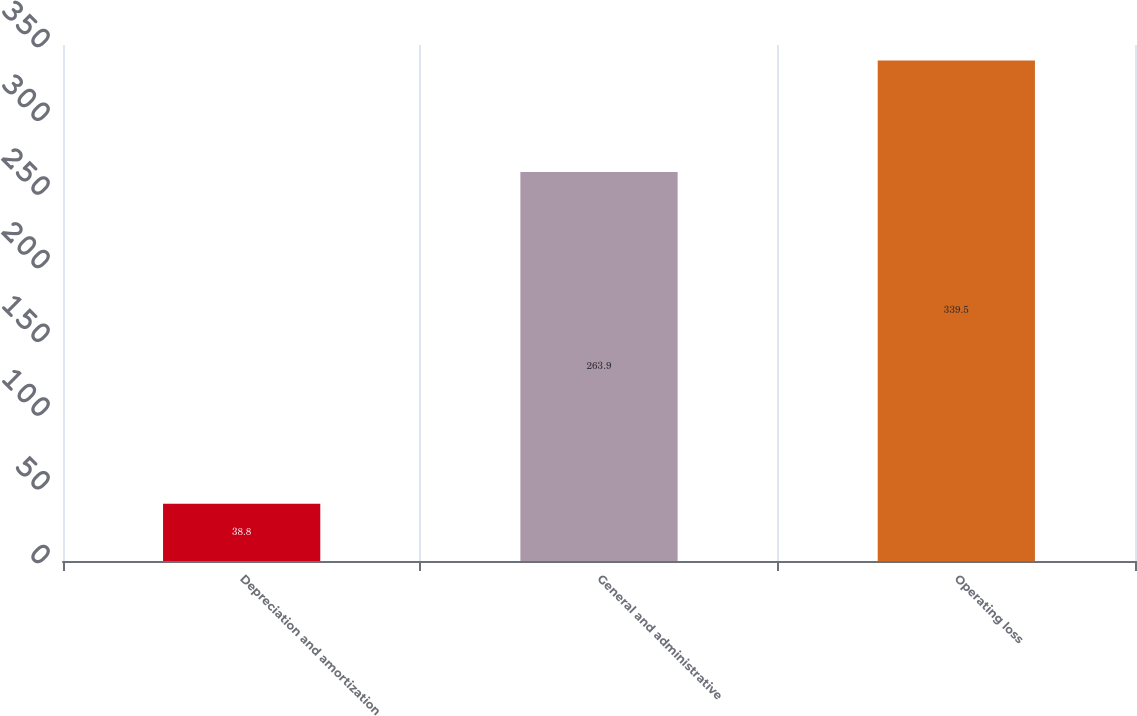Convert chart. <chart><loc_0><loc_0><loc_500><loc_500><bar_chart><fcel>Depreciation and amortization<fcel>General and administrative<fcel>Operating loss<nl><fcel>38.8<fcel>263.9<fcel>339.5<nl></chart> 